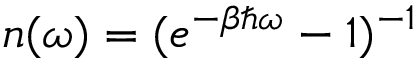Convert formula to latex. <formula><loc_0><loc_0><loc_500><loc_500>n ( \omega ) = ( e ^ { - \beta \hbar { \omega } } - 1 ) ^ { - 1 }</formula> 